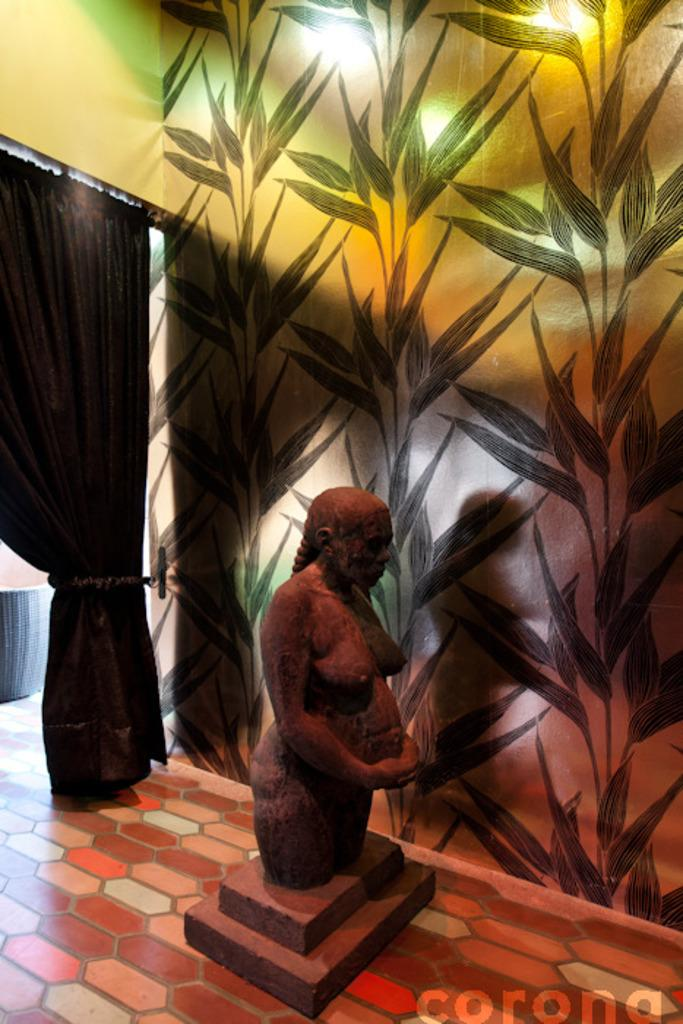What is placed on the table top in the image? There is a small woman statue on the table top. What can be seen on the wall in the image? There is a green color wallpaper on the wall. What type of curtain is present beside the wall? There is a small cotton curtain beside the wall. What position does the snake take in the image? There is no snake present in the image. What thing is placed on the table top, besides the small woman statue? The provided facts do not mention any other objects on the table top besides the small woman statue. 